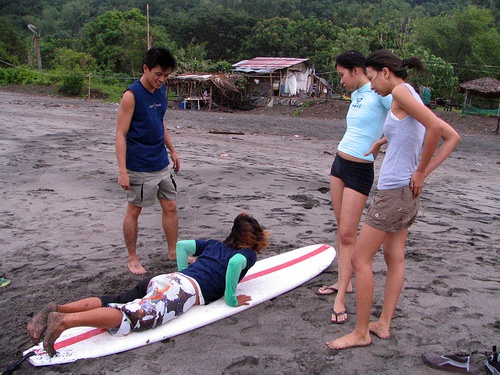Describe the objects in this image and their specific colors. I can see people in black, brown, gray, and darkgray tones, people in black, lavender, navy, and gray tones, people in black, brown, gray, and navy tones, surfboard in black, white, gray, and darkgray tones, and people in black, brown, lightblue, and gray tones in this image. 